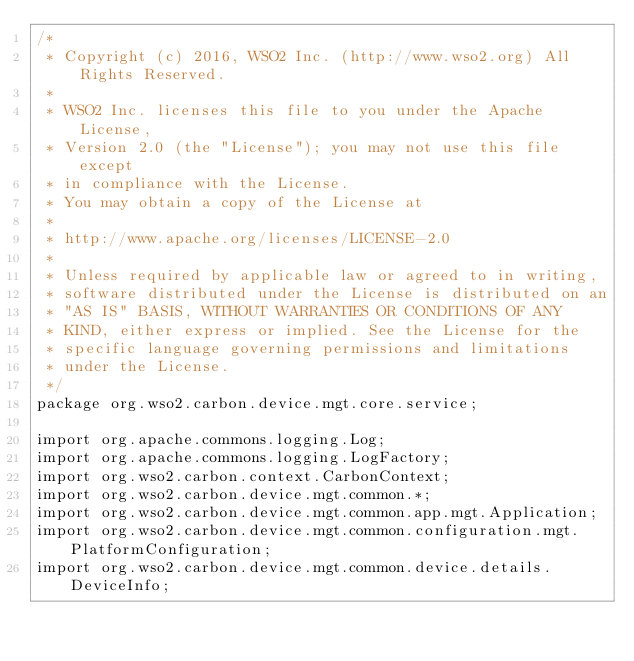<code> <loc_0><loc_0><loc_500><loc_500><_Java_>/*
 * Copyright (c) 2016, WSO2 Inc. (http://www.wso2.org) All Rights Reserved.
 *
 * WSO2 Inc. licenses this file to you under the Apache License,
 * Version 2.0 (the "License"); you may not use this file except
 * in compliance with the License.
 * You may obtain a copy of the License at
 *
 * http://www.apache.org/licenses/LICENSE-2.0
 *
 * Unless required by applicable law or agreed to in writing,
 * software distributed under the License is distributed on an
 * "AS IS" BASIS, WITHOUT WARRANTIES OR CONDITIONS OF ANY
 * KIND, either express or implied. See the License for the
 * specific language governing permissions and limitations
 * under the License.
 */
package org.wso2.carbon.device.mgt.core.service;

import org.apache.commons.logging.Log;
import org.apache.commons.logging.LogFactory;
import org.wso2.carbon.context.CarbonContext;
import org.wso2.carbon.device.mgt.common.*;
import org.wso2.carbon.device.mgt.common.app.mgt.Application;
import org.wso2.carbon.device.mgt.common.configuration.mgt.PlatformConfiguration;
import org.wso2.carbon.device.mgt.common.device.details.DeviceInfo;</code> 